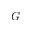Convert formula to latex. <formula><loc_0><loc_0><loc_500><loc_500>G</formula> 